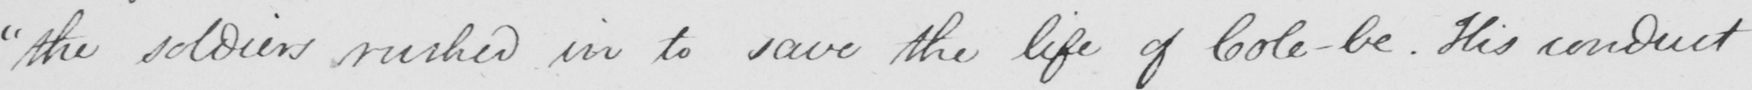Please provide the text content of this handwritten line. " the soldiers rushed in to save the life of Cole-be . His conduct 